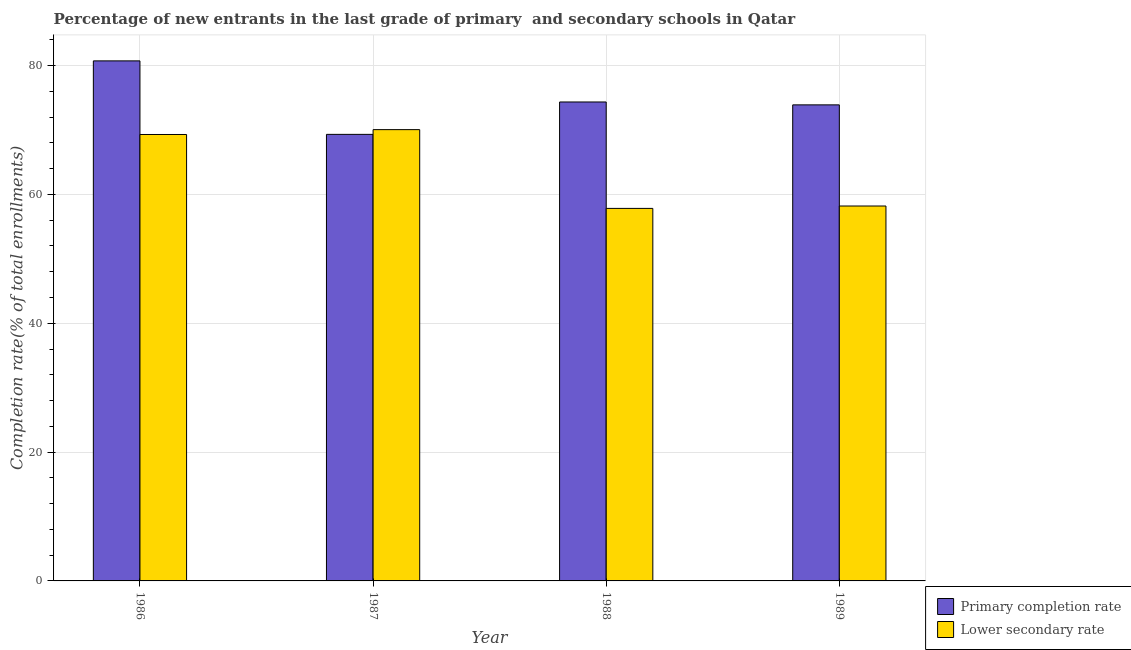How many different coloured bars are there?
Ensure brevity in your answer.  2. Are the number of bars on each tick of the X-axis equal?
Make the answer very short. Yes. What is the completion rate in secondary schools in 1988?
Offer a terse response. 57.83. Across all years, what is the maximum completion rate in secondary schools?
Ensure brevity in your answer.  70.06. Across all years, what is the minimum completion rate in secondary schools?
Ensure brevity in your answer.  57.83. In which year was the completion rate in primary schools maximum?
Your answer should be compact. 1986. What is the total completion rate in secondary schools in the graph?
Your answer should be compact. 255.39. What is the difference between the completion rate in secondary schools in 1987 and that in 1988?
Make the answer very short. 12.23. What is the difference between the completion rate in secondary schools in 1988 and the completion rate in primary schools in 1987?
Offer a terse response. -12.23. What is the average completion rate in primary schools per year?
Your answer should be compact. 74.58. In how many years, is the completion rate in primary schools greater than 80 %?
Your response must be concise. 1. What is the ratio of the completion rate in primary schools in 1987 to that in 1989?
Provide a succinct answer. 0.94. What is the difference between the highest and the second highest completion rate in secondary schools?
Your answer should be compact. 0.75. What is the difference between the highest and the lowest completion rate in primary schools?
Keep it short and to the point. 11.41. What does the 1st bar from the left in 1989 represents?
Your answer should be compact. Primary completion rate. What does the 1st bar from the right in 1987 represents?
Ensure brevity in your answer.  Lower secondary rate. How many bars are there?
Make the answer very short. 8. Are all the bars in the graph horizontal?
Offer a terse response. No. How many years are there in the graph?
Keep it short and to the point. 4. Are the values on the major ticks of Y-axis written in scientific E-notation?
Provide a short and direct response. No. Does the graph contain any zero values?
Provide a short and direct response. No. How are the legend labels stacked?
Offer a terse response. Vertical. What is the title of the graph?
Your answer should be compact. Percentage of new entrants in the last grade of primary  and secondary schools in Qatar. Does "Short-term debt" appear as one of the legend labels in the graph?
Offer a terse response. No. What is the label or title of the X-axis?
Provide a short and direct response. Year. What is the label or title of the Y-axis?
Provide a short and direct response. Completion rate(% of total enrollments). What is the Completion rate(% of total enrollments) in Primary completion rate in 1986?
Your answer should be compact. 80.73. What is the Completion rate(% of total enrollments) in Lower secondary rate in 1986?
Your answer should be compact. 69.3. What is the Completion rate(% of total enrollments) in Primary completion rate in 1987?
Give a very brief answer. 69.32. What is the Completion rate(% of total enrollments) of Lower secondary rate in 1987?
Your answer should be compact. 70.06. What is the Completion rate(% of total enrollments) of Primary completion rate in 1988?
Provide a short and direct response. 74.35. What is the Completion rate(% of total enrollments) of Lower secondary rate in 1988?
Your answer should be very brief. 57.83. What is the Completion rate(% of total enrollments) of Primary completion rate in 1989?
Ensure brevity in your answer.  73.9. What is the Completion rate(% of total enrollments) of Lower secondary rate in 1989?
Offer a terse response. 58.2. Across all years, what is the maximum Completion rate(% of total enrollments) of Primary completion rate?
Offer a very short reply. 80.73. Across all years, what is the maximum Completion rate(% of total enrollments) in Lower secondary rate?
Your answer should be compact. 70.06. Across all years, what is the minimum Completion rate(% of total enrollments) in Primary completion rate?
Your response must be concise. 69.32. Across all years, what is the minimum Completion rate(% of total enrollments) of Lower secondary rate?
Provide a short and direct response. 57.83. What is the total Completion rate(% of total enrollments) in Primary completion rate in the graph?
Your answer should be compact. 298.31. What is the total Completion rate(% of total enrollments) in Lower secondary rate in the graph?
Your answer should be very brief. 255.39. What is the difference between the Completion rate(% of total enrollments) in Primary completion rate in 1986 and that in 1987?
Offer a terse response. 11.41. What is the difference between the Completion rate(% of total enrollments) of Lower secondary rate in 1986 and that in 1987?
Provide a succinct answer. -0.75. What is the difference between the Completion rate(% of total enrollments) in Primary completion rate in 1986 and that in 1988?
Make the answer very short. 6.38. What is the difference between the Completion rate(% of total enrollments) in Lower secondary rate in 1986 and that in 1988?
Provide a succinct answer. 11.47. What is the difference between the Completion rate(% of total enrollments) of Primary completion rate in 1986 and that in 1989?
Your response must be concise. 6.83. What is the difference between the Completion rate(% of total enrollments) in Lower secondary rate in 1986 and that in 1989?
Keep it short and to the point. 11.1. What is the difference between the Completion rate(% of total enrollments) in Primary completion rate in 1987 and that in 1988?
Your answer should be compact. -5.03. What is the difference between the Completion rate(% of total enrollments) in Lower secondary rate in 1987 and that in 1988?
Your answer should be very brief. 12.23. What is the difference between the Completion rate(% of total enrollments) of Primary completion rate in 1987 and that in 1989?
Keep it short and to the point. -4.58. What is the difference between the Completion rate(% of total enrollments) of Lower secondary rate in 1987 and that in 1989?
Give a very brief answer. 11.86. What is the difference between the Completion rate(% of total enrollments) in Primary completion rate in 1988 and that in 1989?
Give a very brief answer. 0.45. What is the difference between the Completion rate(% of total enrollments) in Lower secondary rate in 1988 and that in 1989?
Your response must be concise. -0.37. What is the difference between the Completion rate(% of total enrollments) in Primary completion rate in 1986 and the Completion rate(% of total enrollments) in Lower secondary rate in 1987?
Your answer should be very brief. 10.67. What is the difference between the Completion rate(% of total enrollments) in Primary completion rate in 1986 and the Completion rate(% of total enrollments) in Lower secondary rate in 1988?
Provide a succinct answer. 22.9. What is the difference between the Completion rate(% of total enrollments) of Primary completion rate in 1986 and the Completion rate(% of total enrollments) of Lower secondary rate in 1989?
Give a very brief answer. 22.53. What is the difference between the Completion rate(% of total enrollments) of Primary completion rate in 1987 and the Completion rate(% of total enrollments) of Lower secondary rate in 1988?
Offer a very short reply. 11.49. What is the difference between the Completion rate(% of total enrollments) in Primary completion rate in 1987 and the Completion rate(% of total enrollments) in Lower secondary rate in 1989?
Provide a succinct answer. 11.12. What is the difference between the Completion rate(% of total enrollments) in Primary completion rate in 1988 and the Completion rate(% of total enrollments) in Lower secondary rate in 1989?
Your answer should be compact. 16.15. What is the average Completion rate(% of total enrollments) of Primary completion rate per year?
Your answer should be very brief. 74.58. What is the average Completion rate(% of total enrollments) of Lower secondary rate per year?
Your answer should be very brief. 63.85. In the year 1986, what is the difference between the Completion rate(% of total enrollments) of Primary completion rate and Completion rate(% of total enrollments) of Lower secondary rate?
Your response must be concise. 11.43. In the year 1987, what is the difference between the Completion rate(% of total enrollments) of Primary completion rate and Completion rate(% of total enrollments) of Lower secondary rate?
Make the answer very short. -0.74. In the year 1988, what is the difference between the Completion rate(% of total enrollments) of Primary completion rate and Completion rate(% of total enrollments) of Lower secondary rate?
Give a very brief answer. 16.52. In the year 1989, what is the difference between the Completion rate(% of total enrollments) in Primary completion rate and Completion rate(% of total enrollments) in Lower secondary rate?
Provide a succinct answer. 15.7. What is the ratio of the Completion rate(% of total enrollments) in Primary completion rate in 1986 to that in 1987?
Provide a succinct answer. 1.16. What is the ratio of the Completion rate(% of total enrollments) in Lower secondary rate in 1986 to that in 1987?
Ensure brevity in your answer.  0.99. What is the ratio of the Completion rate(% of total enrollments) of Primary completion rate in 1986 to that in 1988?
Offer a very short reply. 1.09. What is the ratio of the Completion rate(% of total enrollments) in Lower secondary rate in 1986 to that in 1988?
Provide a short and direct response. 1.2. What is the ratio of the Completion rate(% of total enrollments) of Primary completion rate in 1986 to that in 1989?
Provide a succinct answer. 1.09. What is the ratio of the Completion rate(% of total enrollments) of Lower secondary rate in 1986 to that in 1989?
Offer a very short reply. 1.19. What is the ratio of the Completion rate(% of total enrollments) in Primary completion rate in 1987 to that in 1988?
Provide a short and direct response. 0.93. What is the ratio of the Completion rate(% of total enrollments) in Lower secondary rate in 1987 to that in 1988?
Keep it short and to the point. 1.21. What is the ratio of the Completion rate(% of total enrollments) of Primary completion rate in 1987 to that in 1989?
Give a very brief answer. 0.94. What is the ratio of the Completion rate(% of total enrollments) of Lower secondary rate in 1987 to that in 1989?
Offer a very short reply. 1.2. What is the difference between the highest and the second highest Completion rate(% of total enrollments) of Primary completion rate?
Provide a short and direct response. 6.38. What is the difference between the highest and the second highest Completion rate(% of total enrollments) in Lower secondary rate?
Your response must be concise. 0.75. What is the difference between the highest and the lowest Completion rate(% of total enrollments) of Primary completion rate?
Offer a terse response. 11.41. What is the difference between the highest and the lowest Completion rate(% of total enrollments) in Lower secondary rate?
Keep it short and to the point. 12.23. 